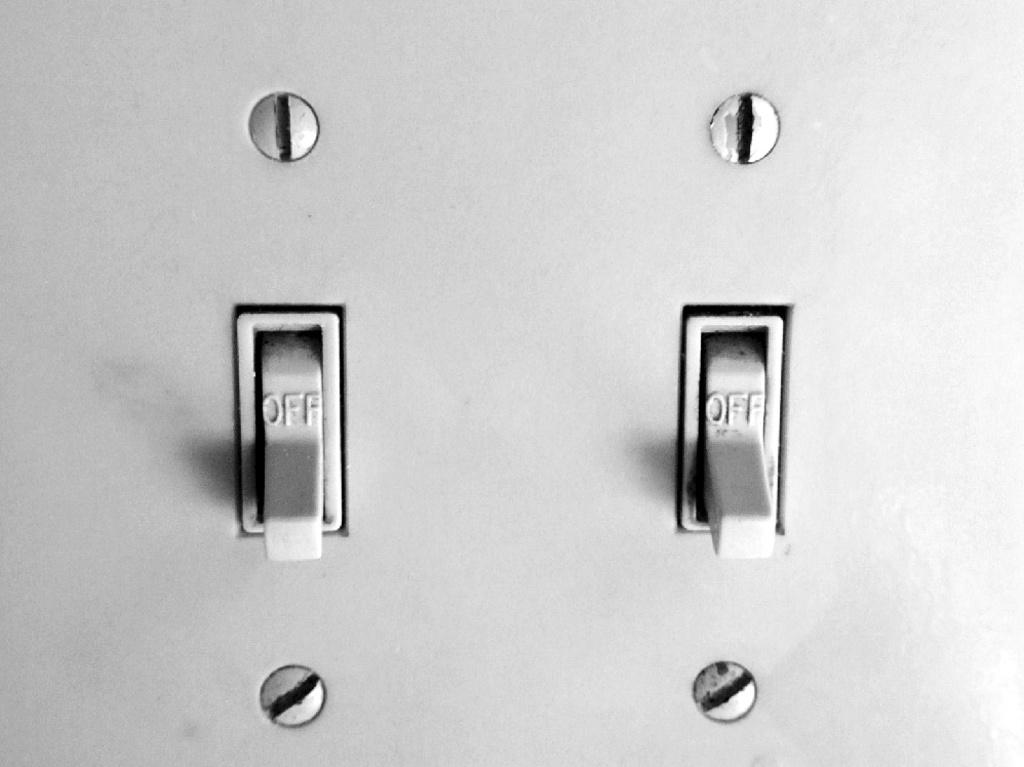<image>
Write a terse but informative summary of the picture. Two light switches are in the off position. 